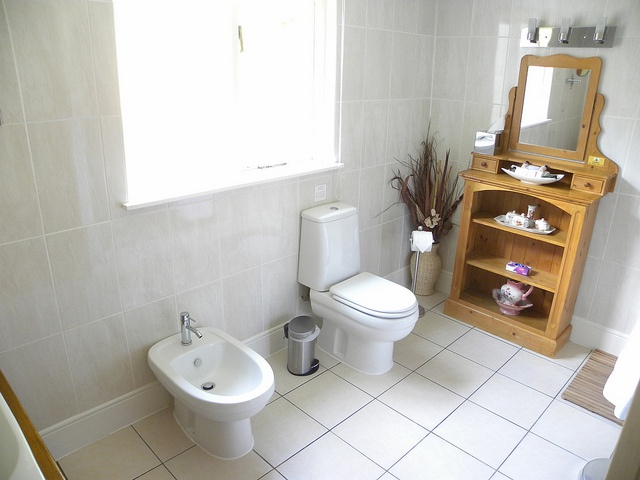Describe the objects in this image and their specific colors. I can see toilet in gray, lightgray, and darkgray tones and vase in gray and lightgray tones in this image. 